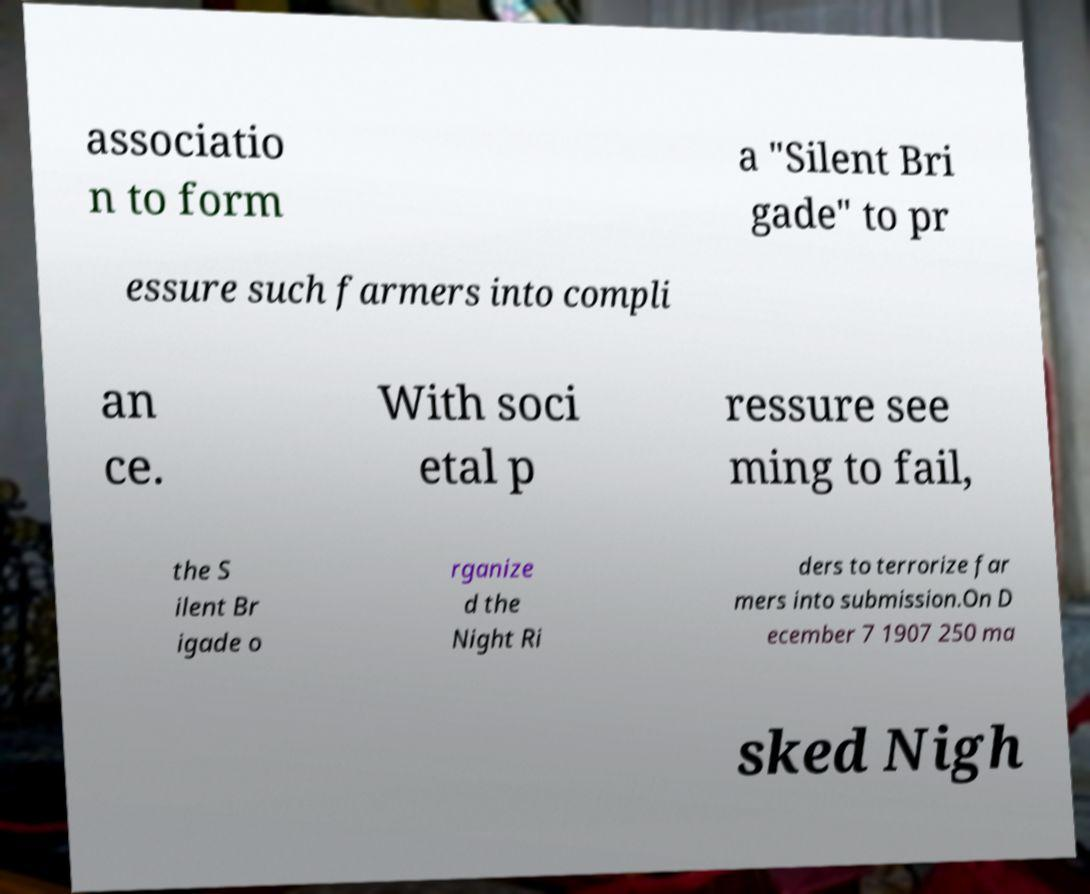What messages or text are displayed in this image? I need them in a readable, typed format. associatio n to form a "Silent Bri gade" to pr essure such farmers into compli an ce. With soci etal p ressure see ming to fail, the S ilent Br igade o rganize d the Night Ri ders to terrorize far mers into submission.On D ecember 7 1907 250 ma sked Nigh 